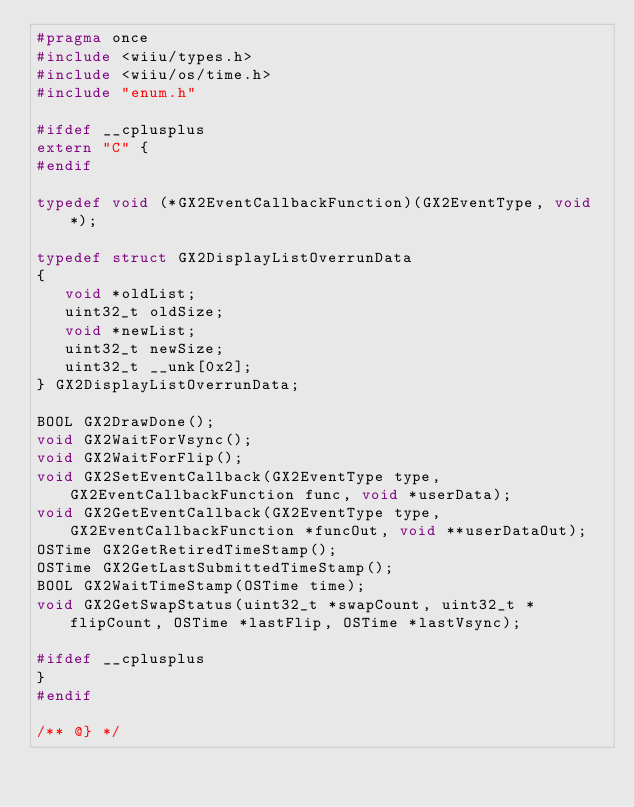Convert code to text. <code><loc_0><loc_0><loc_500><loc_500><_C_>#pragma once
#include <wiiu/types.h>
#include <wiiu/os/time.h>
#include "enum.h"

#ifdef __cplusplus
extern "C" {
#endif

typedef void (*GX2EventCallbackFunction)(GX2EventType, void *);

typedef struct GX2DisplayListOverrunData
{
   void *oldList;
   uint32_t oldSize;
   void *newList;
   uint32_t newSize;
   uint32_t __unk[0x2];
} GX2DisplayListOverrunData;

BOOL GX2DrawDone();
void GX2WaitForVsync();
void GX2WaitForFlip();
void GX2SetEventCallback(GX2EventType type, GX2EventCallbackFunction func, void *userData);
void GX2GetEventCallback(GX2EventType type, GX2EventCallbackFunction *funcOut, void **userDataOut);
OSTime GX2GetRetiredTimeStamp();
OSTime GX2GetLastSubmittedTimeStamp();
BOOL GX2WaitTimeStamp(OSTime time);
void GX2GetSwapStatus(uint32_t *swapCount, uint32_t *flipCount, OSTime *lastFlip, OSTime *lastVsync);

#ifdef __cplusplus
}
#endif

/** @} */
</code> 